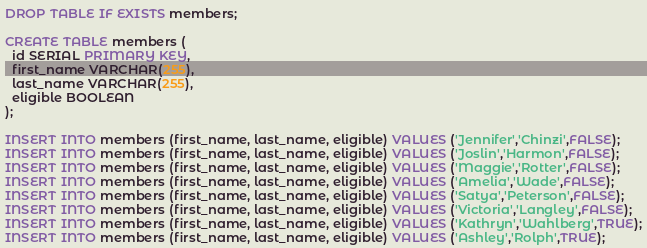<code> <loc_0><loc_0><loc_500><loc_500><_SQL_>DROP TABLE IF EXISTS members;

CREATE TABLE members (
  id SERIAL PRIMARY KEY,
  first_name VARCHAR(255),
  last_name VARCHAR(255),
  eligible BOOLEAN
);

INSERT INTO members (first_name, last_name, eligible) VALUES ('Jennifer','Chinzi',FALSE);
INSERT INTO members (first_name, last_name, eligible) VALUES ('Joslin','Harmon',FALSE);
INSERT INTO members (first_name, last_name, eligible) VALUES ('Maggie','Rotter',FALSE);
INSERT INTO members (first_name, last_name, eligible) VALUES ('Amelia','Wade',FALSE);
INSERT INTO members (first_name, last_name, eligible) VALUES ('Satya','Peterson',FALSE);
INSERT INTO members (first_name, last_name, eligible) VALUES ('Victoria','Langley',FALSE);
INSERT INTO members (first_name, last_name, eligible) VALUES ('Kathryn','Wahlberg',TRUE);
INSERT INTO members (first_name, last_name, eligible) VALUES ('Ashley','Rolph',TRUE);</code> 